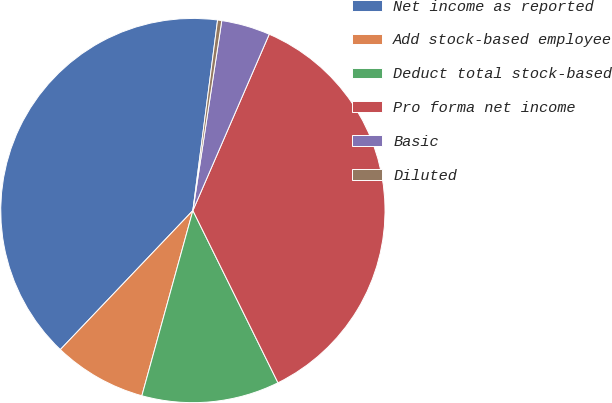Convert chart. <chart><loc_0><loc_0><loc_500><loc_500><pie_chart><fcel>Net income as reported<fcel>Add stock-based employee<fcel>Deduct total stock-based<fcel>Pro forma net income<fcel>Basic<fcel>Diluted<nl><fcel>39.93%<fcel>7.84%<fcel>11.58%<fcel>36.19%<fcel>4.1%<fcel>0.35%<nl></chart> 